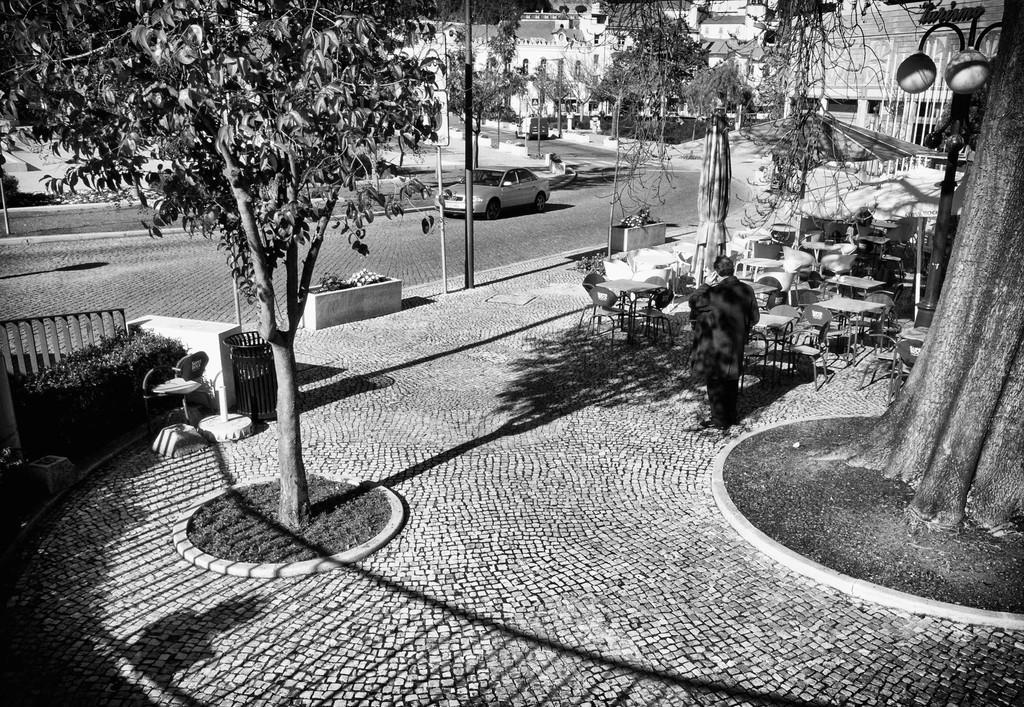Could you give a brief overview of what you see in this image? It is the black and white image in which there is a man standing on the floor. Beside the man there are tables and chairs. On the right side there is a big tree. On the left side there is a road on which there is a car. In the background there are buildings. On the left side there is a dustbin on the floor. Beside the dustbin there is a tree. 